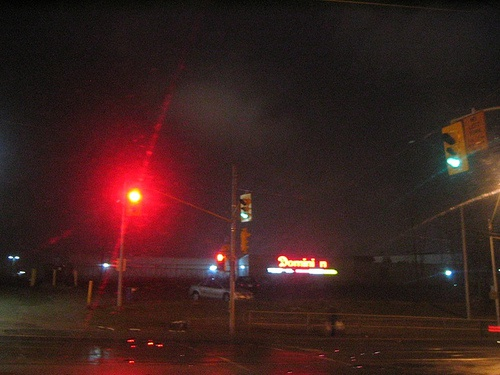Describe the objects in this image and their specific colors. I can see car in black, maroon, gray, and white tones, car in black, maroon, gray, and purple tones, traffic light in black, brown, maroon, and olive tones, traffic light in black, maroon, and brown tones, and traffic light in black, red, orange, and salmon tones in this image. 